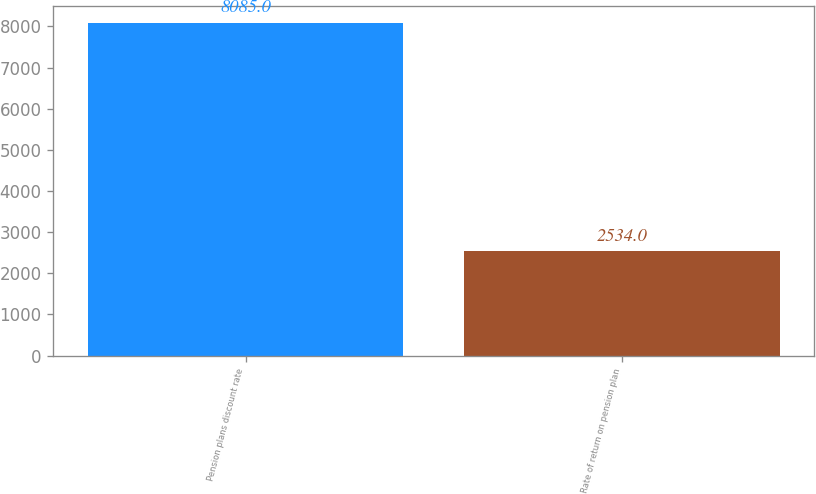Convert chart to OTSL. <chart><loc_0><loc_0><loc_500><loc_500><bar_chart><fcel>Pension plans discount rate<fcel>Rate of return on pension plan<nl><fcel>8085<fcel>2534<nl></chart> 